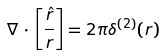Convert formula to latex. <formula><loc_0><loc_0><loc_500><loc_500>{ \nabla } \, \cdot \, \left [ \frac { \hat { r } } { r } \right ] = 2 \pi \delta ^ { ( 2 ) } ( { r } ) \,</formula> 